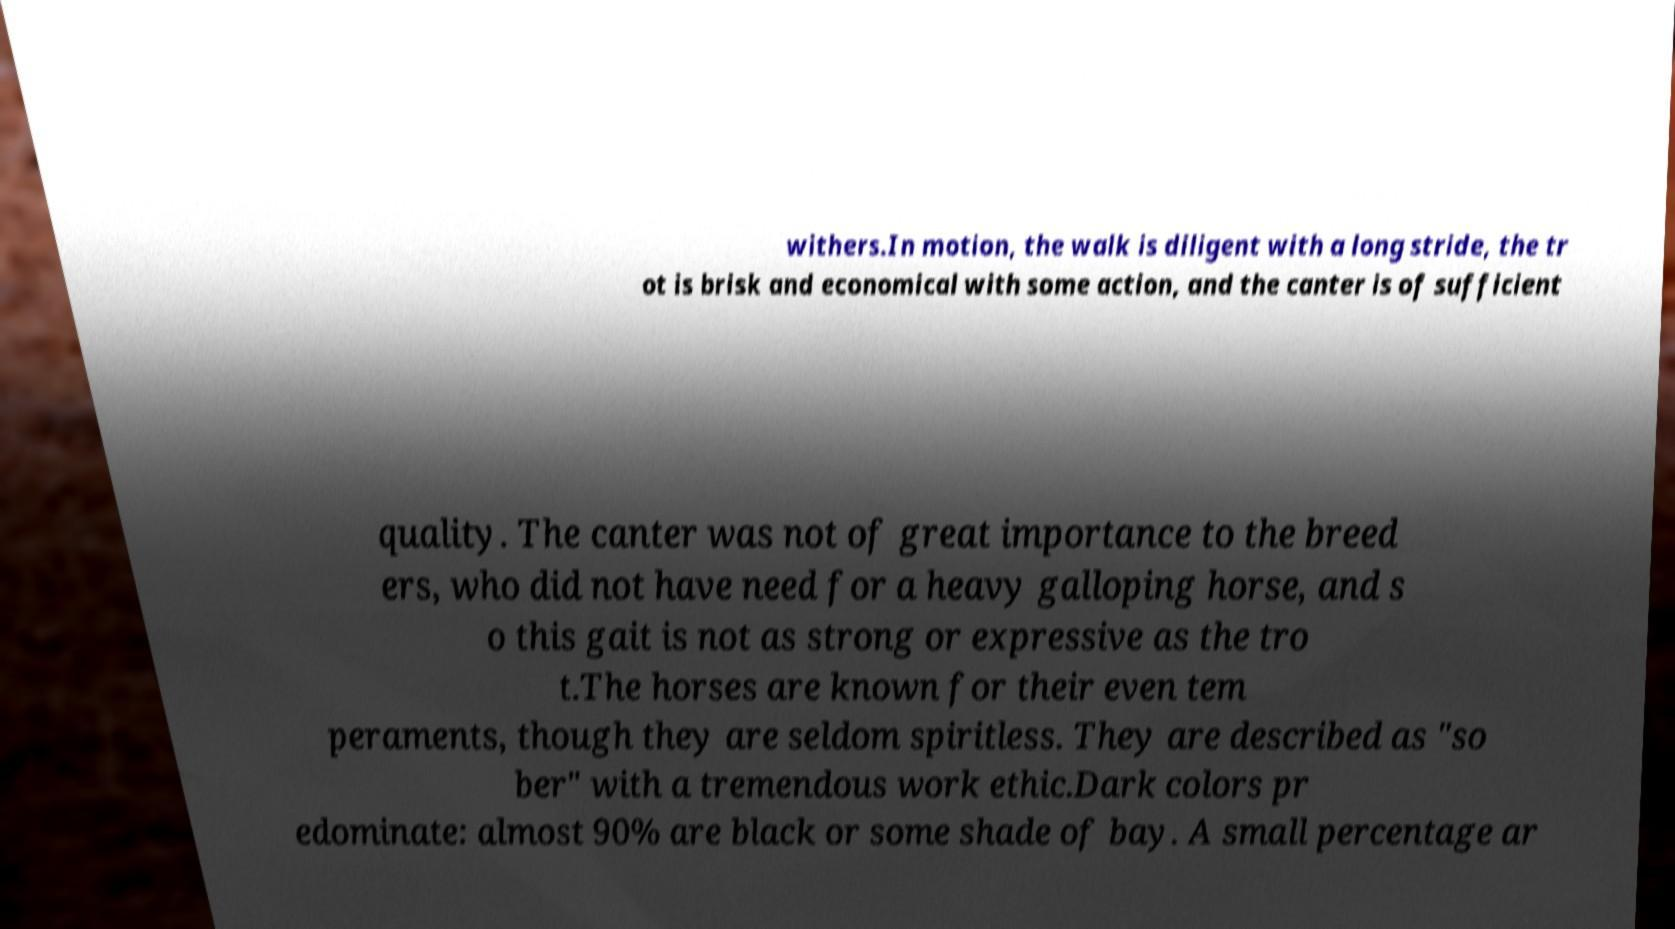Can you accurately transcribe the text from the provided image for me? withers.In motion, the walk is diligent with a long stride, the tr ot is brisk and economical with some action, and the canter is of sufficient quality. The canter was not of great importance to the breed ers, who did not have need for a heavy galloping horse, and s o this gait is not as strong or expressive as the tro t.The horses are known for their even tem peraments, though they are seldom spiritless. They are described as "so ber" with a tremendous work ethic.Dark colors pr edominate: almost 90% are black or some shade of bay. A small percentage ar 